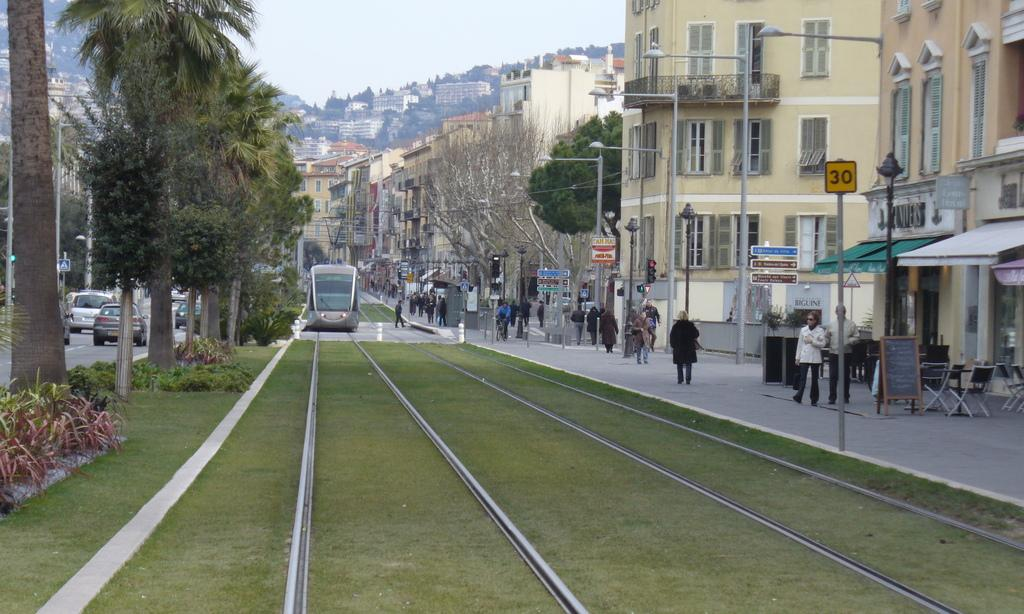What is the main subject of the image? The main subject of the image is a locomotive on the track. What else can be seen in the image besides the locomotive? There are persons walking on the road, motor vehicles, bushes, trees, buildings, street poles, and street lights visible in the image. Can you describe the road in the image? The road has persons walking on it and motor vehicles driving on it. What type of vegetation is present in the image? Bushes and trees are present in the image. What structures can be seen in the image? Buildings are present in the image. What type of street infrastructure is visible in the image? Street poles and street lights are visible in the image. What is visible in the sky in the image? The sky is visible in the image. How many times does the person on the swing say good-bye in the image? There is no person on a swing present in the image, so it is not possible to determine how many times they might say good-bye. 